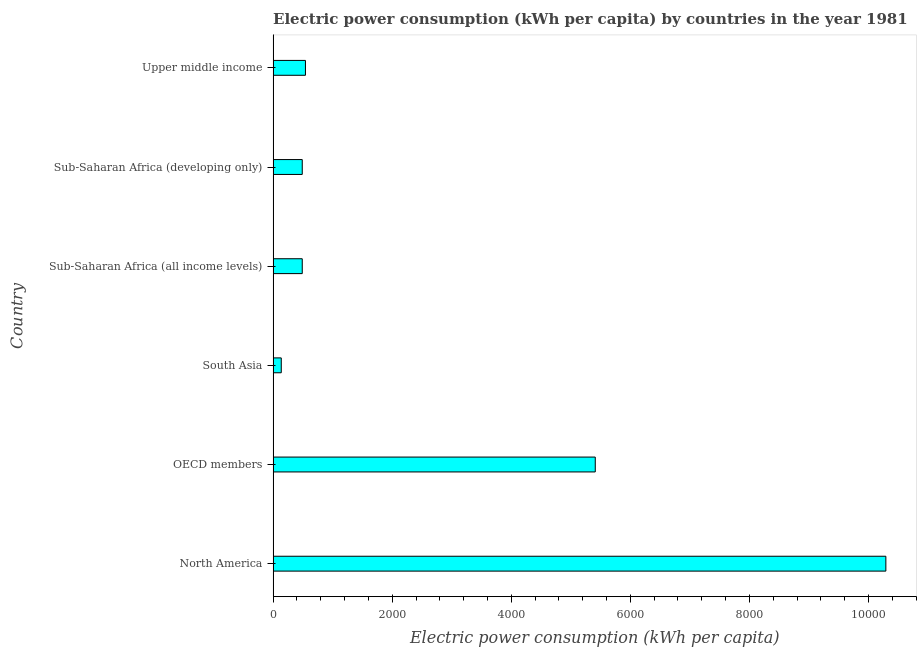Does the graph contain any zero values?
Provide a succinct answer. No. What is the title of the graph?
Offer a terse response. Electric power consumption (kWh per capita) by countries in the year 1981. What is the label or title of the X-axis?
Offer a very short reply. Electric power consumption (kWh per capita). What is the electric power consumption in Sub-Saharan Africa (developing only)?
Give a very brief answer. 489.28. Across all countries, what is the maximum electric power consumption?
Ensure brevity in your answer.  1.03e+04. Across all countries, what is the minimum electric power consumption?
Provide a succinct answer. 136.78. What is the sum of the electric power consumption?
Keep it short and to the point. 1.74e+04. What is the difference between the electric power consumption in Sub-Saharan Africa (all income levels) and Upper middle income?
Keep it short and to the point. -53.79. What is the average electric power consumption per country?
Make the answer very short. 2893.53. What is the median electric power consumption?
Give a very brief answer. 516.18. In how many countries, is the electric power consumption greater than 6400 kWh per capita?
Your answer should be compact. 1. What is the ratio of the electric power consumption in OECD members to that in Sub-Saharan Africa (developing only)?
Offer a terse response. 11.06. Is the electric power consumption in OECD members less than that in Sub-Saharan Africa (all income levels)?
Give a very brief answer. No. What is the difference between the highest and the second highest electric power consumption?
Ensure brevity in your answer.  4881.07. Is the sum of the electric power consumption in OECD members and South Asia greater than the maximum electric power consumption across all countries?
Offer a terse response. No. What is the difference between the highest and the lowest electric power consumption?
Offer a terse response. 1.02e+04. Are all the bars in the graph horizontal?
Offer a very short reply. Yes. Are the values on the major ticks of X-axis written in scientific E-notation?
Your answer should be compact. No. What is the Electric power consumption (kWh per capita) in North America?
Make the answer very short. 1.03e+04. What is the Electric power consumption (kWh per capita) in OECD members?
Keep it short and to the point. 5410.84. What is the Electric power consumption (kWh per capita) of South Asia?
Keep it short and to the point. 136.78. What is the Electric power consumption (kWh per capita) in Sub-Saharan Africa (all income levels)?
Give a very brief answer. 489.28. What is the Electric power consumption (kWh per capita) in Sub-Saharan Africa (developing only)?
Your answer should be compact. 489.28. What is the Electric power consumption (kWh per capita) of Upper middle income?
Your answer should be compact. 543.07. What is the difference between the Electric power consumption (kWh per capita) in North America and OECD members?
Offer a very short reply. 4881.07. What is the difference between the Electric power consumption (kWh per capita) in North America and South Asia?
Make the answer very short. 1.02e+04. What is the difference between the Electric power consumption (kWh per capita) in North America and Sub-Saharan Africa (all income levels)?
Make the answer very short. 9802.63. What is the difference between the Electric power consumption (kWh per capita) in North America and Sub-Saharan Africa (developing only)?
Provide a short and direct response. 9802.63. What is the difference between the Electric power consumption (kWh per capita) in North America and Upper middle income?
Offer a terse response. 9748.84. What is the difference between the Electric power consumption (kWh per capita) in OECD members and South Asia?
Offer a very short reply. 5274.06. What is the difference between the Electric power consumption (kWh per capita) in OECD members and Sub-Saharan Africa (all income levels)?
Your answer should be very brief. 4921.56. What is the difference between the Electric power consumption (kWh per capita) in OECD members and Sub-Saharan Africa (developing only)?
Provide a succinct answer. 4921.56. What is the difference between the Electric power consumption (kWh per capita) in OECD members and Upper middle income?
Provide a short and direct response. 4867.77. What is the difference between the Electric power consumption (kWh per capita) in South Asia and Sub-Saharan Africa (all income levels)?
Make the answer very short. -352.5. What is the difference between the Electric power consumption (kWh per capita) in South Asia and Sub-Saharan Africa (developing only)?
Provide a short and direct response. -352.5. What is the difference between the Electric power consumption (kWh per capita) in South Asia and Upper middle income?
Provide a succinct answer. -406.29. What is the difference between the Electric power consumption (kWh per capita) in Sub-Saharan Africa (all income levels) and Upper middle income?
Provide a short and direct response. -53.79. What is the difference between the Electric power consumption (kWh per capita) in Sub-Saharan Africa (developing only) and Upper middle income?
Offer a very short reply. -53.79. What is the ratio of the Electric power consumption (kWh per capita) in North America to that in OECD members?
Make the answer very short. 1.9. What is the ratio of the Electric power consumption (kWh per capita) in North America to that in South Asia?
Your response must be concise. 75.24. What is the ratio of the Electric power consumption (kWh per capita) in North America to that in Sub-Saharan Africa (all income levels)?
Your answer should be compact. 21.04. What is the ratio of the Electric power consumption (kWh per capita) in North America to that in Sub-Saharan Africa (developing only)?
Offer a very short reply. 21.04. What is the ratio of the Electric power consumption (kWh per capita) in North America to that in Upper middle income?
Offer a very short reply. 18.95. What is the ratio of the Electric power consumption (kWh per capita) in OECD members to that in South Asia?
Keep it short and to the point. 39.56. What is the ratio of the Electric power consumption (kWh per capita) in OECD members to that in Sub-Saharan Africa (all income levels)?
Your answer should be very brief. 11.06. What is the ratio of the Electric power consumption (kWh per capita) in OECD members to that in Sub-Saharan Africa (developing only)?
Offer a very short reply. 11.06. What is the ratio of the Electric power consumption (kWh per capita) in OECD members to that in Upper middle income?
Ensure brevity in your answer.  9.96. What is the ratio of the Electric power consumption (kWh per capita) in South Asia to that in Sub-Saharan Africa (all income levels)?
Give a very brief answer. 0.28. What is the ratio of the Electric power consumption (kWh per capita) in South Asia to that in Sub-Saharan Africa (developing only)?
Provide a short and direct response. 0.28. What is the ratio of the Electric power consumption (kWh per capita) in South Asia to that in Upper middle income?
Give a very brief answer. 0.25. What is the ratio of the Electric power consumption (kWh per capita) in Sub-Saharan Africa (all income levels) to that in Upper middle income?
Ensure brevity in your answer.  0.9. What is the ratio of the Electric power consumption (kWh per capita) in Sub-Saharan Africa (developing only) to that in Upper middle income?
Your response must be concise. 0.9. 